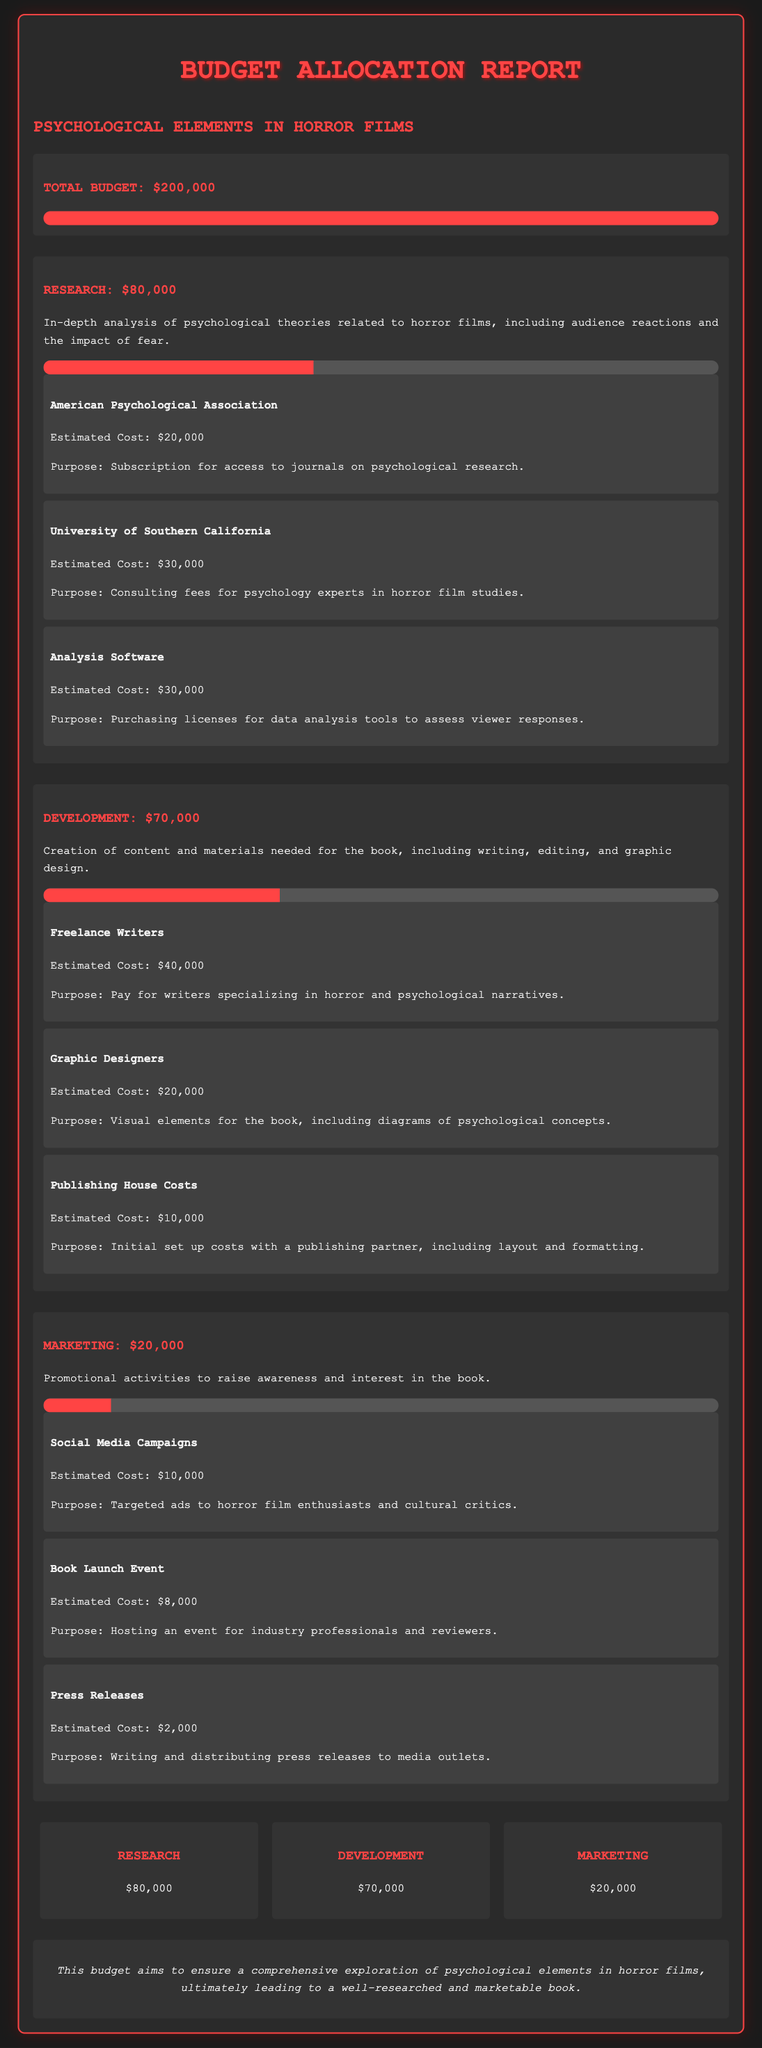What is the total budget? The total budget is explicitly stated in the document as $200,000.
Answer: $200,000 How much is allocated for research? The budget section specifies that $80,000 is allocated for research.
Answer: $80,000 What is the estimated cost for freelance writers? The document lists the estimated cost for freelance writers as $40,000.
Answer: $40,000 What percentage of the marketing budget has been utilized? The progress bar for marketing shows that 10% of the $20,000 budget has been used.
Answer: 10% Which organization is associated with a $20,000 estimated cost? The document mentions the American Psychological Association with an estimated cost of $20,000.
Answer: American Psychological Association What is the total amount allocated for development? The allocated amount for development is clearly stated as $70,000 in the budget section.
Answer: $70,000 What is the purpose of the $30,000 allocated for analysis software? The document explains that the purpose is to purchase licenses for data analysis tools.
Answer: Purchasing licenses for data analysis tools Which marketing item has the highest estimated cost? The document indicates that social media campaigns, with an estimated cost of $10,000, is the highest marketing cost.
Answer: Social Media Campaigns What is the expected outcome of this budget? The document summarizes that the budget aims for a comprehensive exploration of psychological elements.
Answer: Comprehensive exploration of psychological elements 